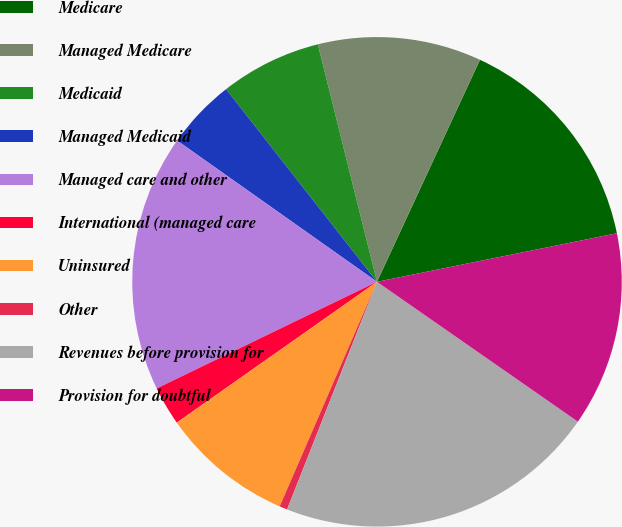Convert chart. <chart><loc_0><loc_0><loc_500><loc_500><pie_chart><fcel>Medicare<fcel>Managed Medicare<fcel>Medicaid<fcel>Managed Medicaid<fcel>Managed care and other<fcel>International (managed care<fcel>Uninsured<fcel>Other<fcel>Revenues before provision for<fcel>Provision for doubtful<nl><fcel>14.91%<fcel>10.8%<fcel>6.69%<fcel>4.63%<fcel>16.97%<fcel>2.58%<fcel>8.74%<fcel>0.52%<fcel>21.31%<fcel>12.86%<nl></chart> 